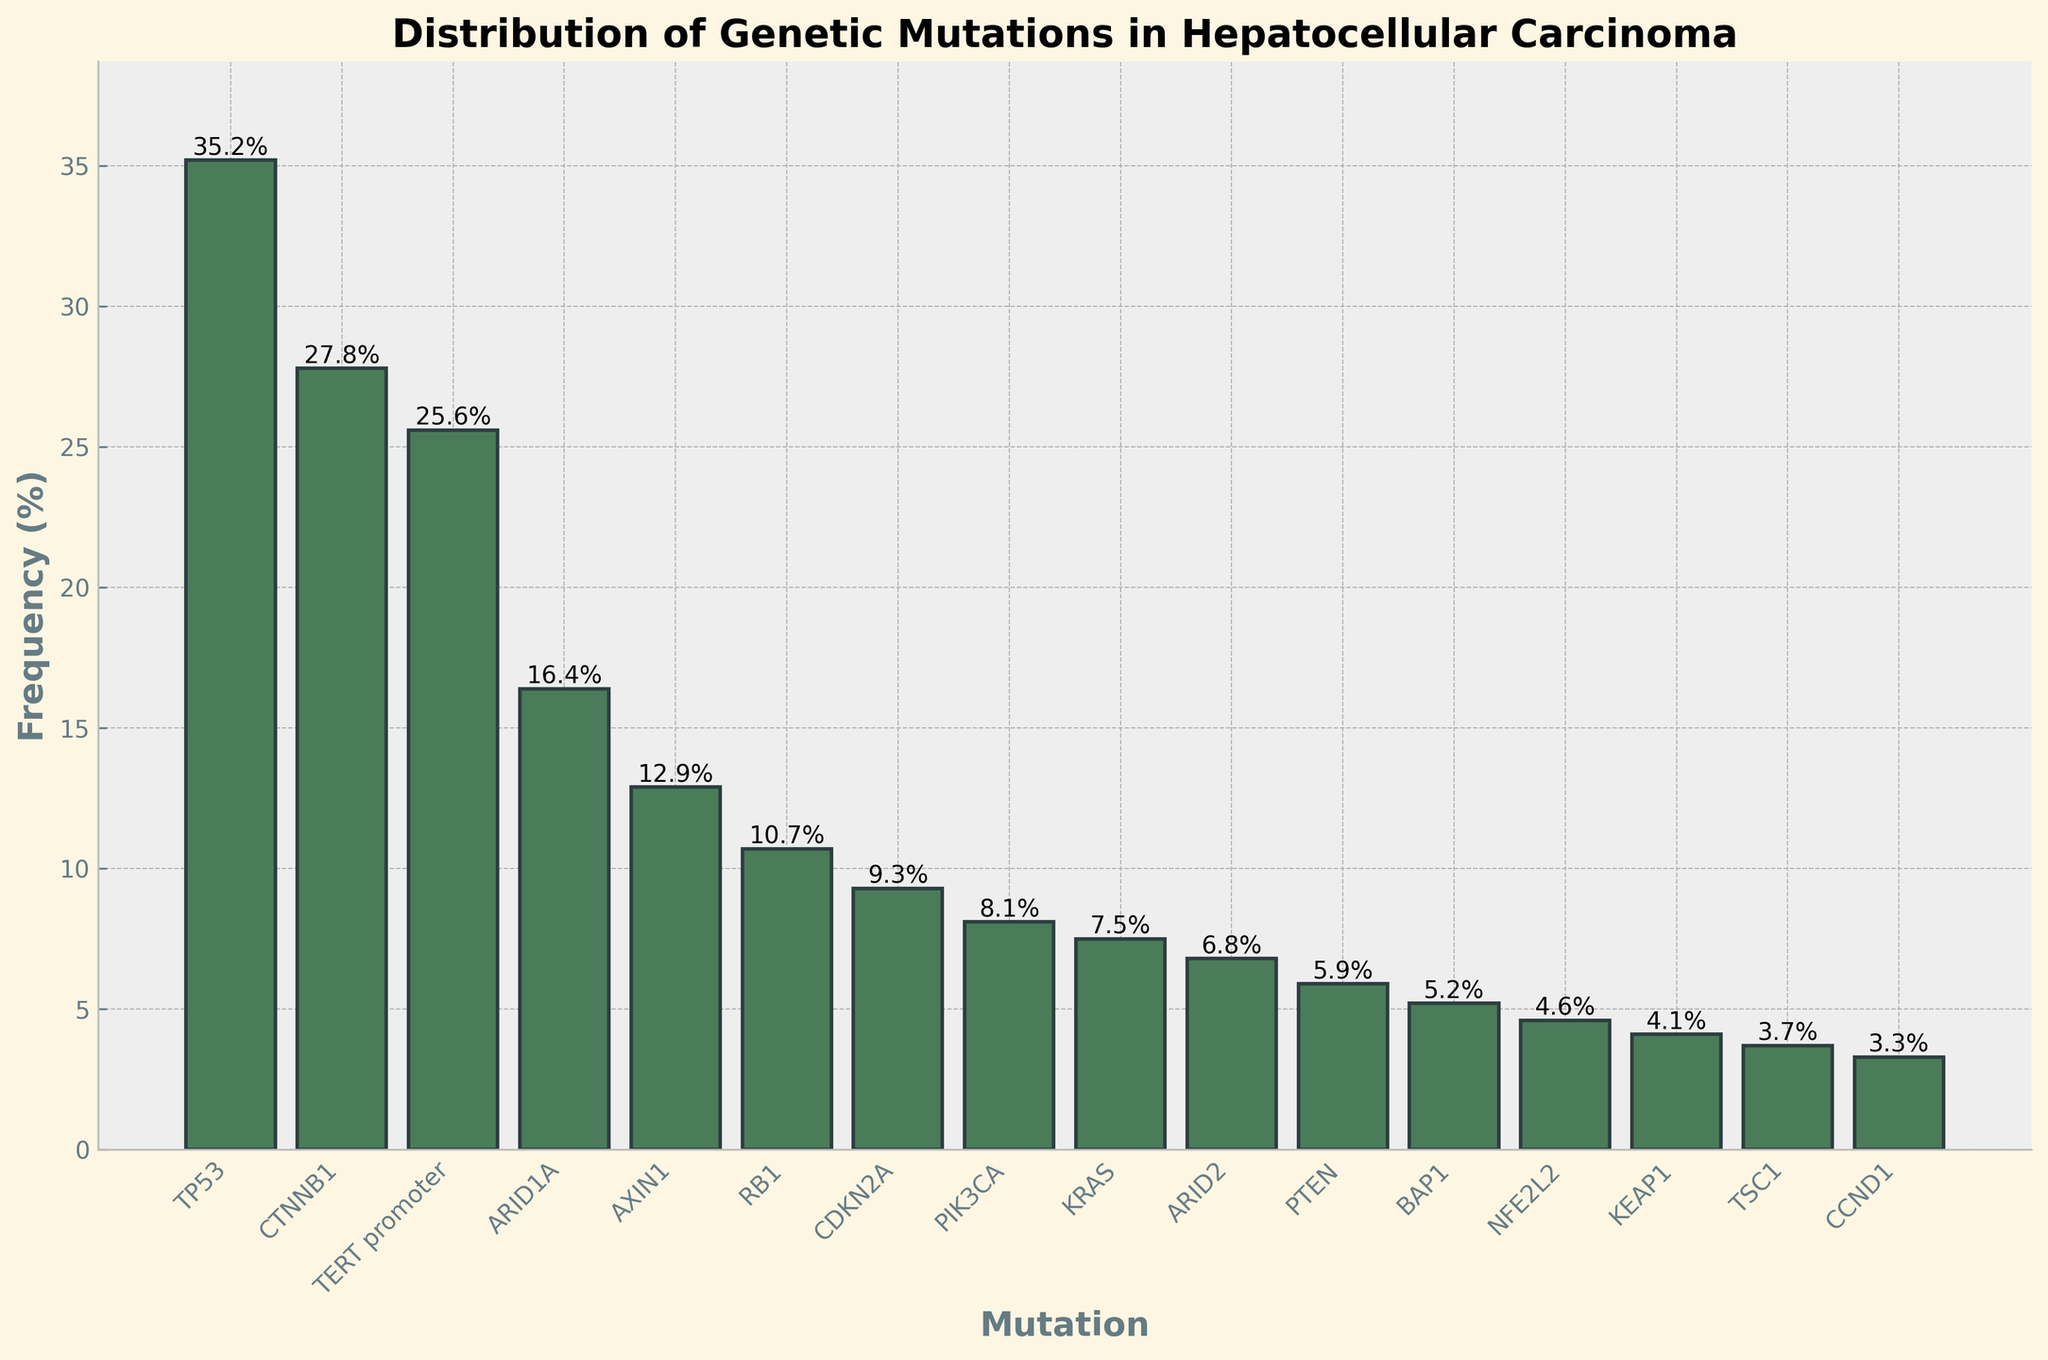What's the most frequently occurring genetic mutation in hepatocellular carcinoma? The y-axis of the bar chart represents the frequency of each genetic mutation. The tallest bar has the label "TP53" with a frequency of 35.2%.
Answer: TP53 Which genetic mutation has a frequency close to 10%? By viewing the bar with a height around 10%, the label is "RB1" with a frequency of 10.7%.
Answer: RB1 Compare the frequencies of CTNNB1 and TERT promoter. Which one is higher and by how much? Locate the bars for CTNNB1 and TERT promoter; CTNNB1 has a frequency of 27.8% and TERT promoter 25.6%. The difference is 27.8% - 25.6% = 2.2%.
Answer: CTNNB1, 2.2% What is the combined frequency of ARID1A and ARID2? Locate the frequencies for ARID1A (16.4%) and ARID2 (6.8%); adding them gives 16.4% + 6.8% = 23.2%.
Answer: 23.2% How many mutations have a frequency lower than 5%? Identify all bars with a frequency below 5%. These mutations are BAP1, NFE2L2, KEAP1, TSC1, and CCND1 (5 in total).
Answer: 5 Which has a higher frequency: PIK3CA or KRAS? By how much? Look at the bars for PIK3CA (8.1%) and KRAS (7.5%). Subtract to find the difference: 8.1% - 7.5% = 0.6%.
Answer: PIK3CA, 0.6% What is the total frequency percentage of the five least frequent mutations? Sum the frequencies of the five smallest bars: BAP1 (5.2%), NFE2L2 (4.6%), KEAP1 (4.1%), TSC1 (3.7%), CCND1 (3.3%). 5.2% + 4.6% + 4.1% + 3.7% + 3.3% = 20.9%.
Answer: 20.9% Among the mutations with a frequency greater than 10%, which one has the lowest frequency? Check the mutations above 10%: TP53, CTNNB1, TERT promoter, ARID1A, AXIN1, and RB1. AXIN1 has the lowest frequency at 12.9%.
Answer: AXIN1 What's the sum of the frequencies of the three most frequent mutations? Sum the top three frequencies: TP53 (35.2%), CTNNB1 (27.8%), TERT promoter (25.6%). 35.2% + 27.8% + 25.6% = 88.6%.
Answer: 88.6% Which mutation has a frequency that is approximately halfway between the frequencies of CDKN2A and ARID2? CDKN2A has a frequency of 9.3% and ARID2 has 6.8%. The midpoint is (9.3 + 6.8) / 2 = 8.05%. The closest mutation is PIK3CA with 8.1%.
Answer: PIK3CA 